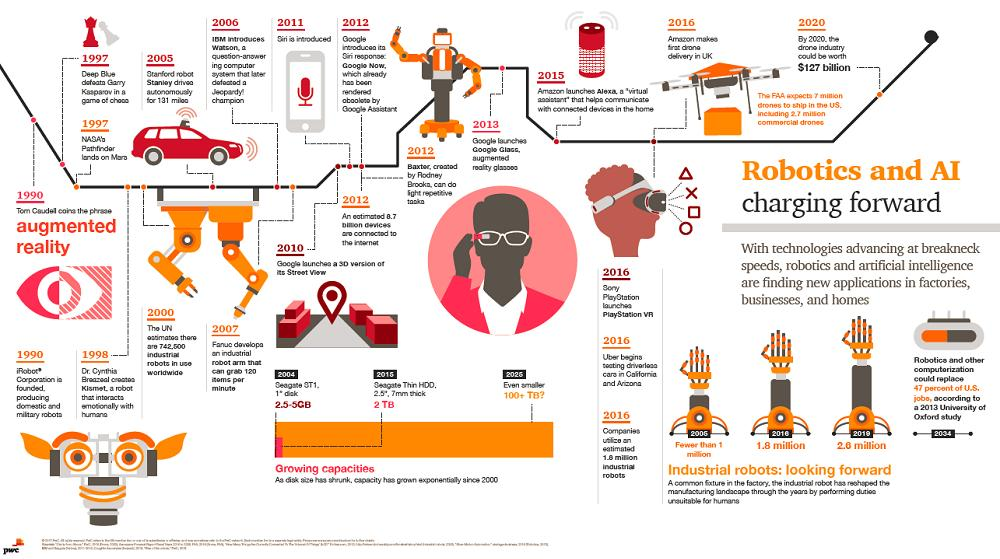List a handful of essential elements in this visual. Google Assistant has made Siri obsolete. Four years have passed since Alexa was launched after Siri was introduced. Tom Caudel introduced augmented reality, which is a technology that superimposes digital information onto the real world. The red car was driven by Stanford robot Stanley. Uber conducted testing of driverless cars in California and Arizona. 